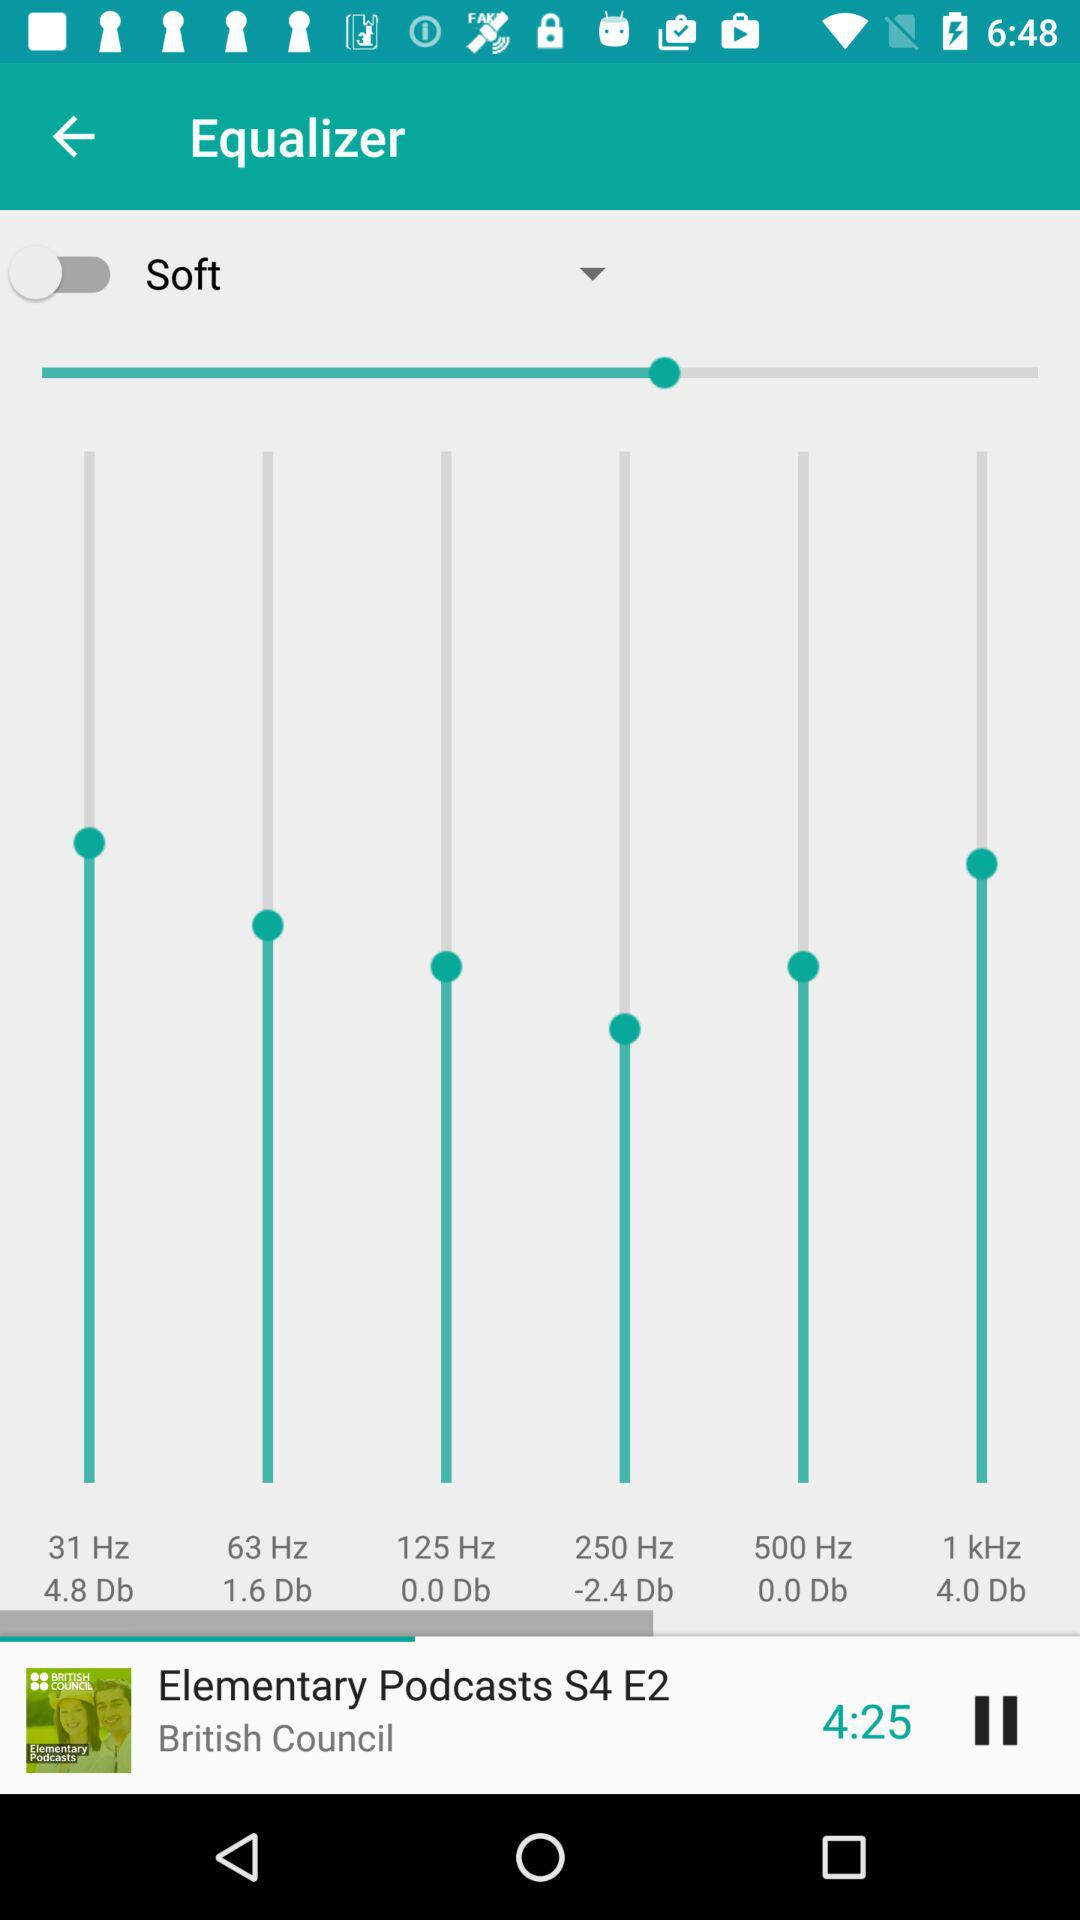What is the duration of the currently playing episode of the series? The duration is 4 minutes 25 seconds. 